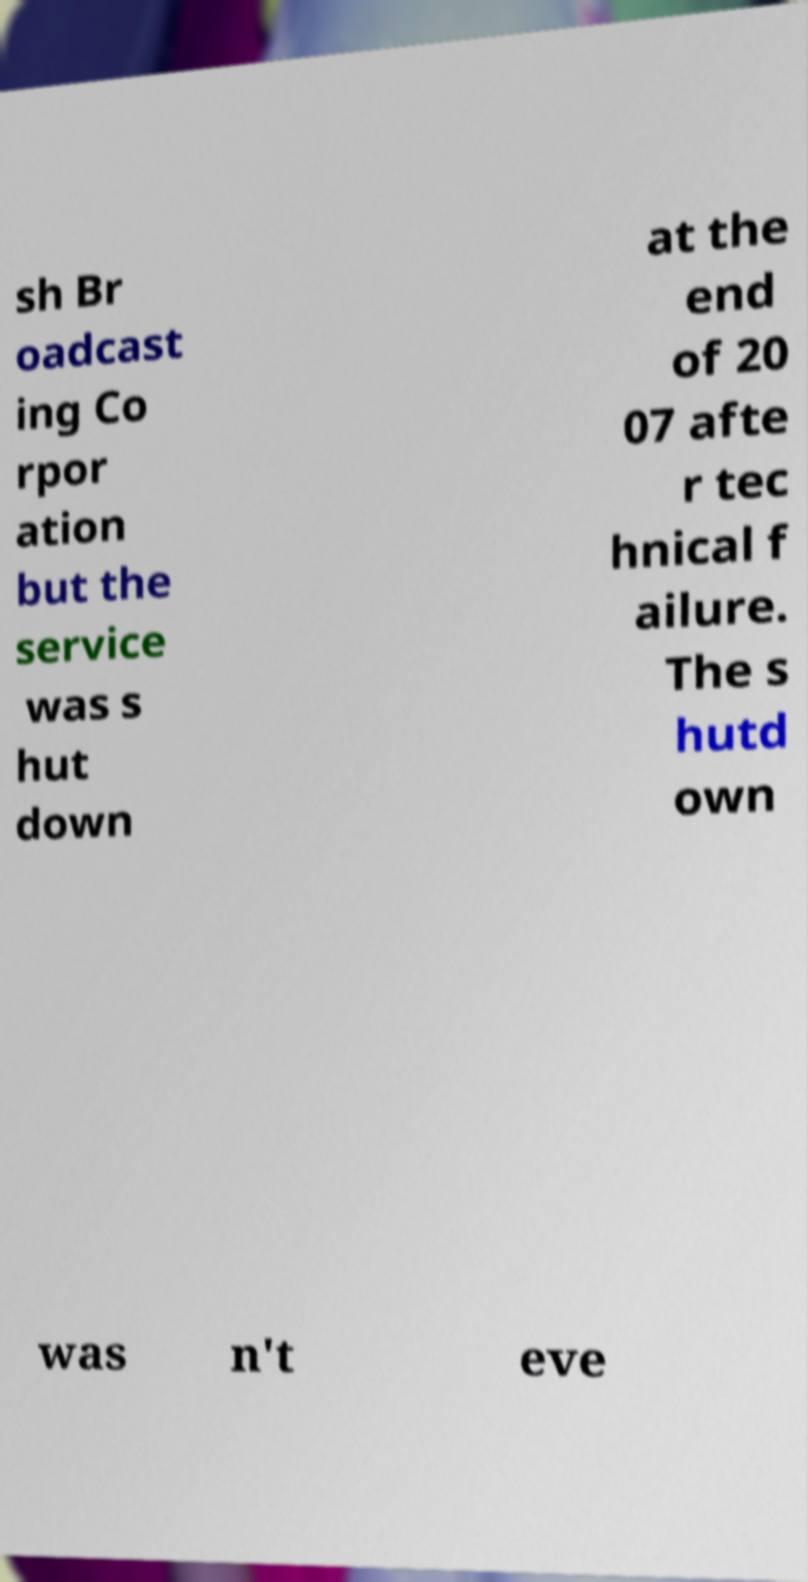Can you accurately transcribe the text from the provided image for me? sh Br oadcast ing Co rpor ation but the service was s hut down at the end of 20 07 afte r tec hnical f ailure. The s hutd own was n't eve 